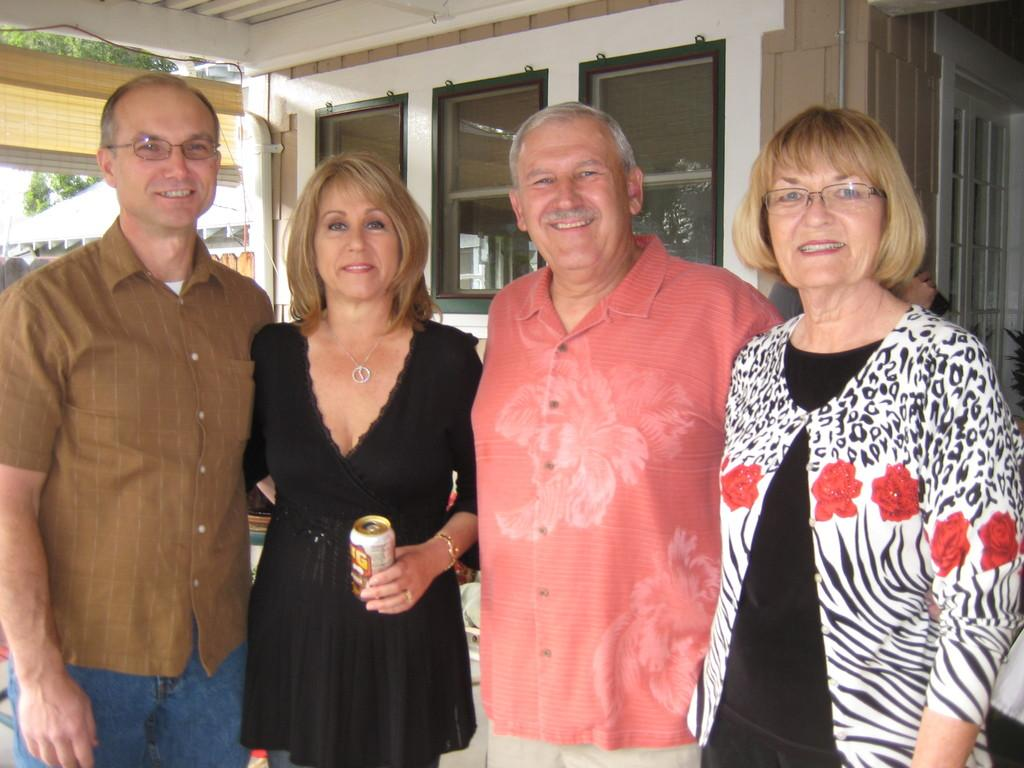How many people are in the image? There are four persons standing in the image. What is the facial expression of the people in the image? The persons are smiling. What can be seen in the background of the image? There are glass windows, trees, and a roof visible in the background of the image. Where is the door located in the image? There is a door on the right side of the image. What type of force is being applied to the dolls in the image? There are no dolls present in the image, so the concept of force cannot be applied. 